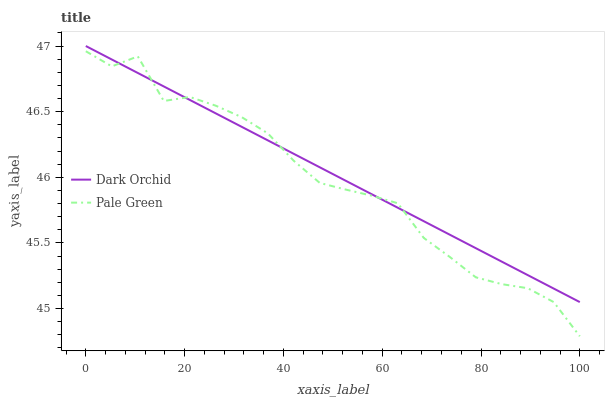Does Dark Orchid have the minimum area under the curve?
Answer yes or no. No. Is Dark Orchid the roughest?
Answer yes or no. No. Does Dark Orchid have the lowest value?
Answer yes or no. No. 